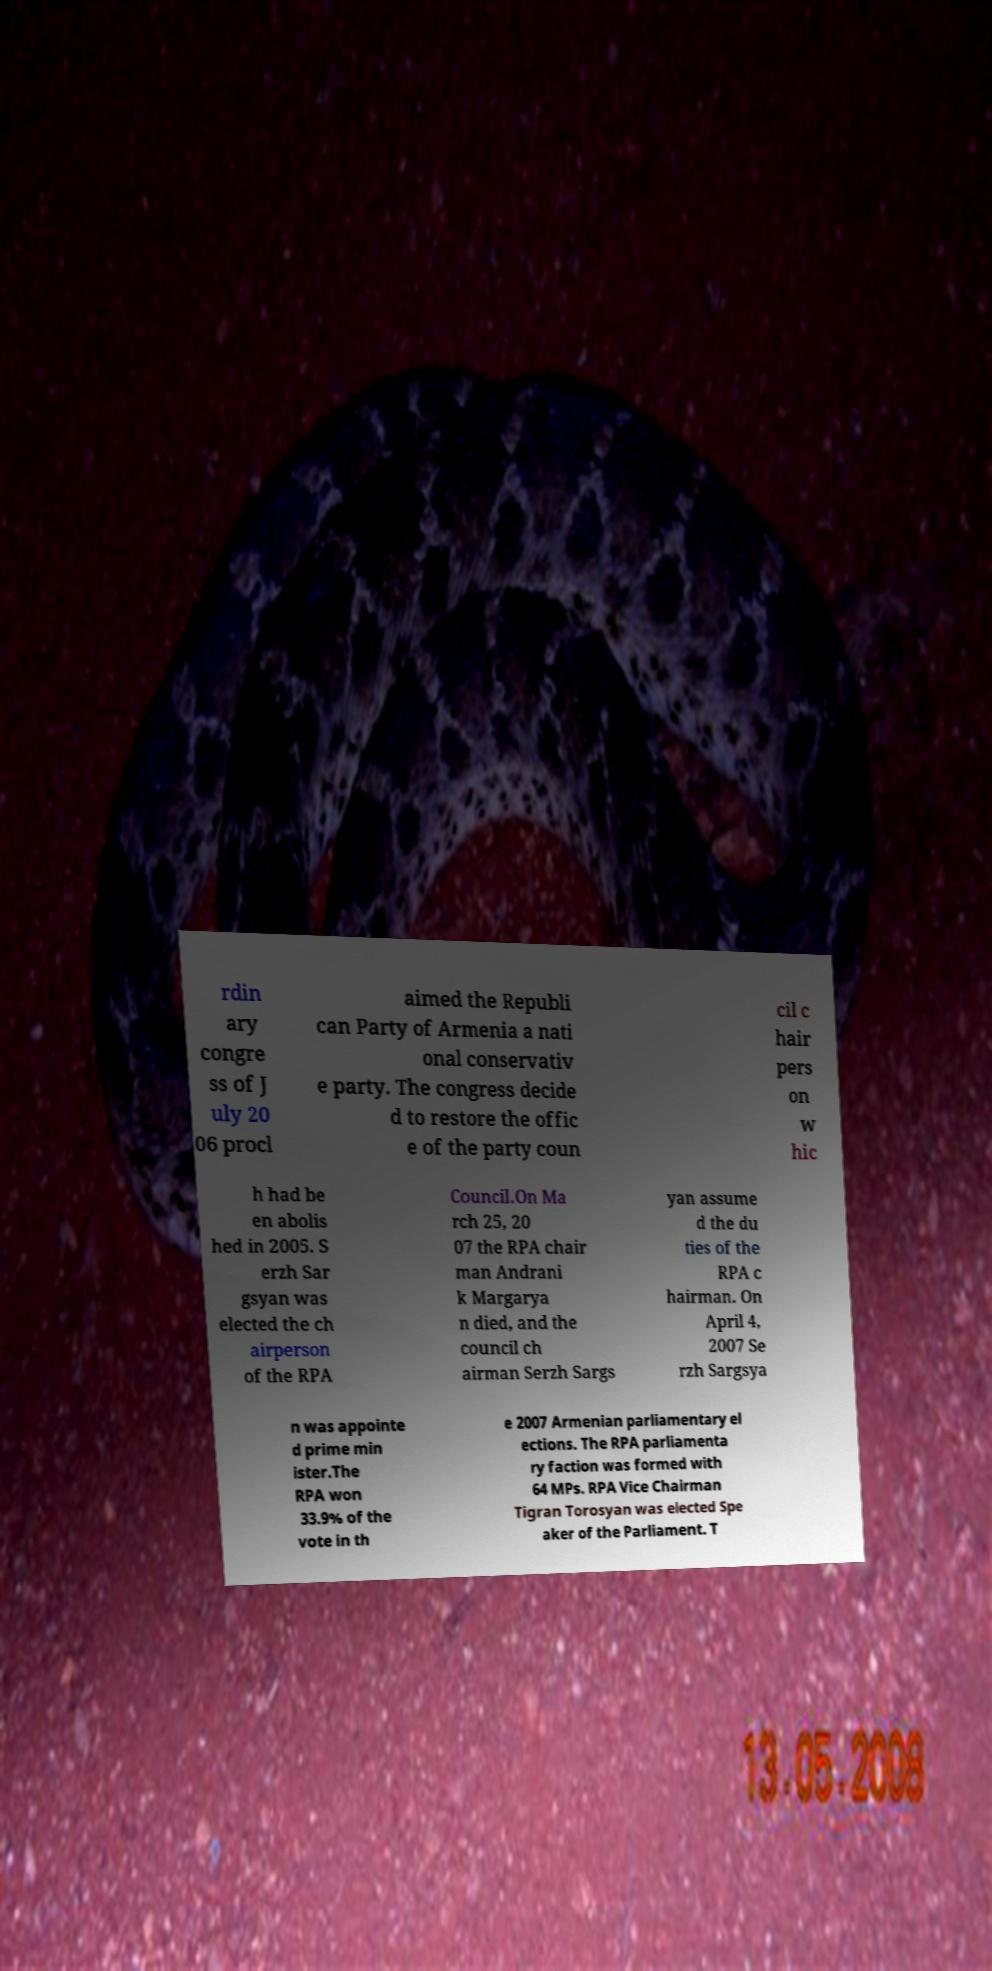Please read and relay the text visible in this image. What does it say? rdin ary congre ss of J uly 20 06 procl aimed the Republi can Party of Armenia a nati onal conservativ e party. The congress decide d to restore the offic e of the party coun cil c hair pers on w hic h had be en abolis hed in 2005. S erzh Sar gsyan was elected the ch airperson of the RPA Council.On Ma rch 25, 20 07 the RPA chair man Andrani k Margarya n died, and the council ch airman Serzh Sargs yan assume d the du ties of the RPA c hairman. On April 4, 2007 Se rzh Sargsya n was appointe d prime min ister.The RPA won 33.9% of the vote in th e 2007 Armenian parliamentary el ections. The RPA parliamenta ry faction was formed with 64 MPs. RPA Vice Chairman Tigran Torosyan was elected Spe aker of the Parliament. T 